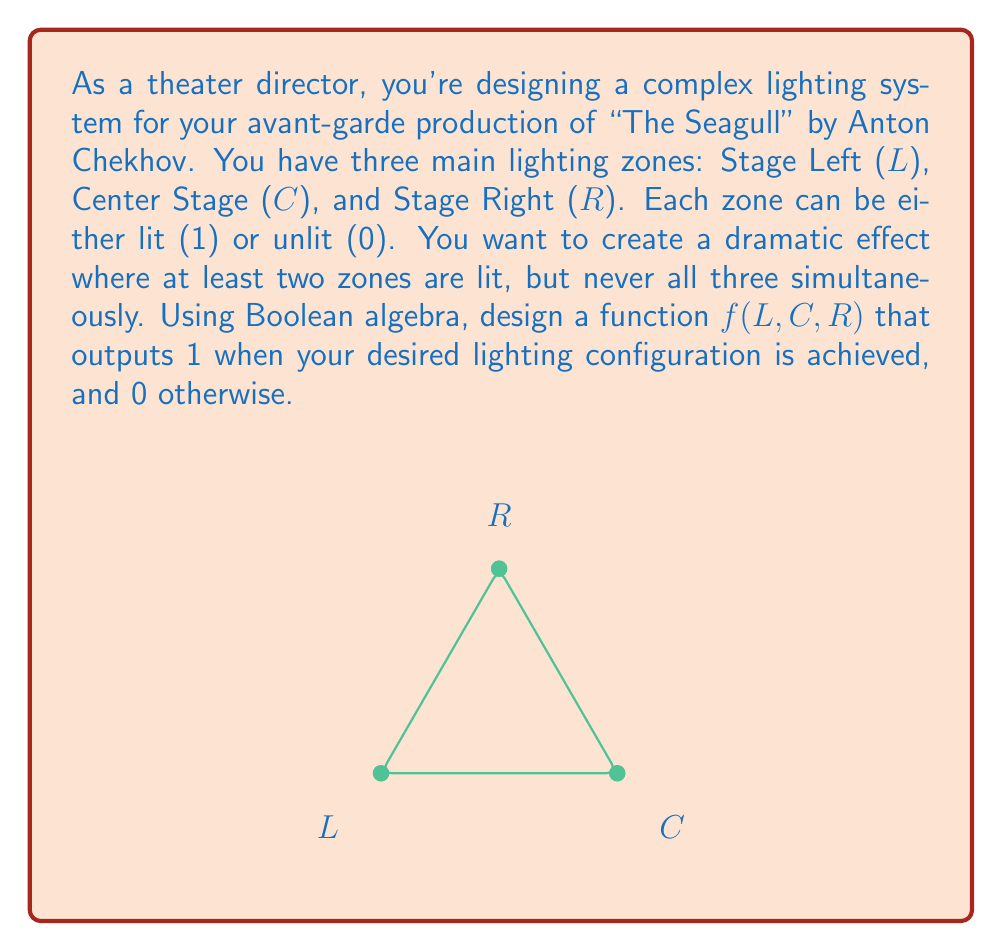Can you solve this math problem? Let's approach this step-by-step:

1) First, we need to identify the conditions for our desired lighting configurations:
   - At least two zones are lit
   - Not all three zones are lit simultaneously

2) We can express these conditions using Boolean algebra:
   - At least two zones lit: $(L \land C) \lor (L \land R) \lor (C \land R)$
   - Not all three lit: $\lnot(L \land C \land R)$

3) Our function should be true when both these conditions are met. In Boolean algebra, this is represented by the AND operation:

   $f(L,C,R) = [(L \land C) \lor (L \land R) \lor (C \land R)] \land [\lnot(L \land C \land R)]$

4) We can simplify this expression using Boolean algebra laws:

   $f(L,C,R) = (L \land C \land \lnot R) \lor (L \land \lnot C \land R) \lor (\lnot L \land C \land R)$

5) This simplified form directly represents the three possible configurations where exactly two zones are lit.

6) We can verify this function:
   - It returns 1 for (1,1,0), (1,0,1), and (0,1,1)
   - It returns 0 for (0,0,0), (1,1,1), and all cases where only one zone is lit

This Boolean function effectively designs the desired stage lighting configuration.
Answer: $f(L,C,R) = (L \land C \land \lnot R) \lor (L \land \lnot C \land R) \lor (\lnot L \land C \land R)$ 